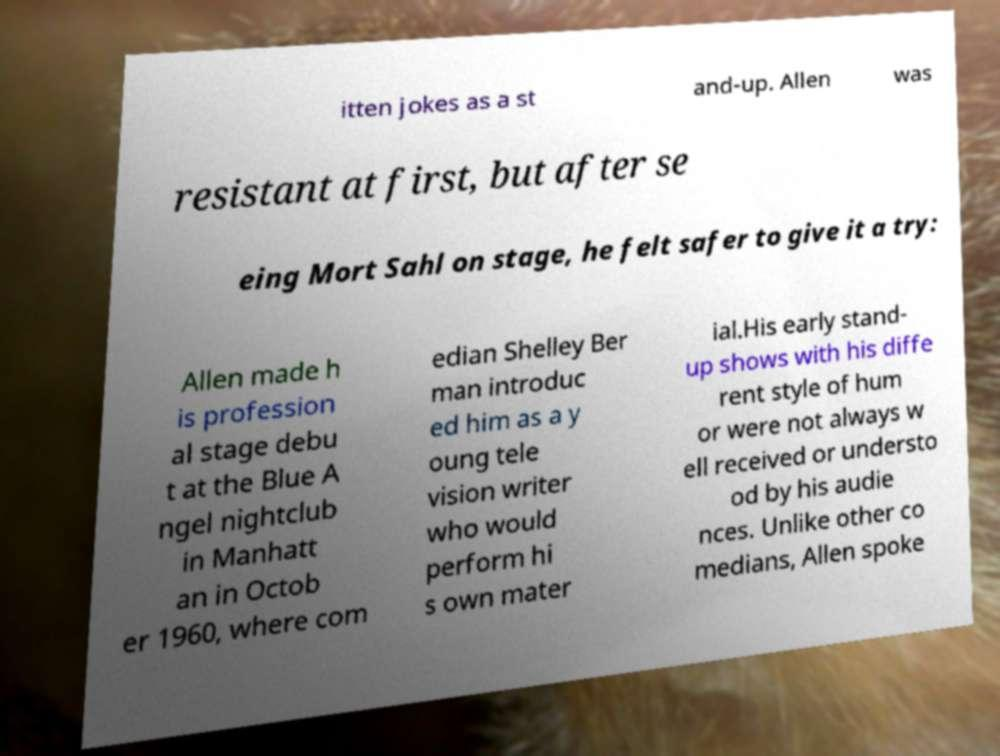There's text embedded in this image that I need extracted. Can you transcribe it verbatim? itten jokes as a st and-up. Allen was resistant at first, but after se eing Mort Sahl on stage, he felt safer to give it a try: Allen made h is profession al stage debu t at the Blue A ngel nightclub in Manhatt an in Octob er 1960, where com edian Shelley Ber man introduc ed him as a y oung tele vision writer who would perform hi s own mater ial.His early stand- up shows with his diffe rent style of hum or were not always w ell received or understo od by his audie nces. Unlike other co medians, Allen spoke 